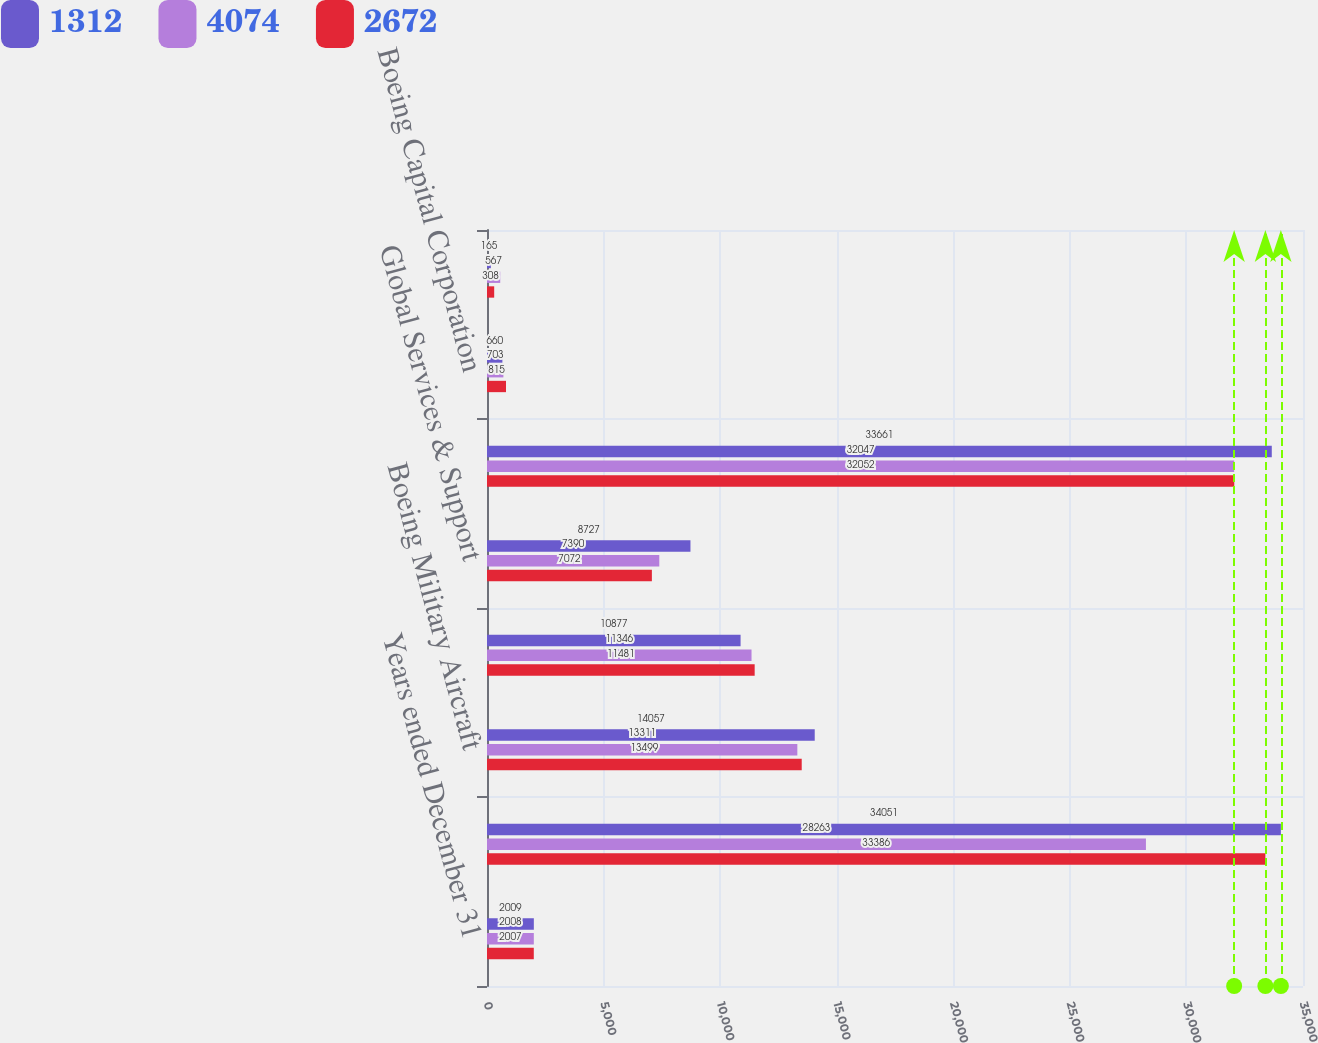<chart> <loc_0><loc_0><loc_500><loc_500><stacked_bar_chart><ecel><fcel>Years ended December 31<fcel>Commercial Airplanes<fcel>Boeing Military Aircraft<fcel>Network & Space Systems<fcel>Global Services & Support<fcel>Total Boeing Defense Space &<fcel>Boeing Capital Corporation<fcel>Other segment<nl><fcel>1312<fcel>2009<fcel>34051<fcel>14057<fcel>10877<fcel>8727<fcel>33661<fcel>660<fcel>165<nl><fcel>4074<fcel>2008<fcel>28263<fcel>13311<fcel>11346<fcel>7390<fcel>32047<fcel>703<fcel>567<nl><fcel>2672<fcel>2007<fcel>33386<fcel>13499<fcel>11481<fcel>7072<fcel>32052<fcel>815<fcel>308<nl></chart> 